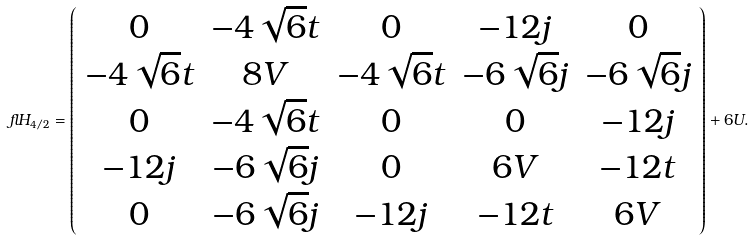<formula> <loc_0><loc_0><loc_500><loc_500>\ f l H _ { 4 / 2 } = \left ( \begin{array} { c c c c c } 0 & - 4 \sqrt { 6 } t & 0 & - 1 2 j & 0 \\ - 4 \sqrt { 6 } t & 8 V & - 4 \sqrt { 6 } t & - 6 \sqrt { 6 } j & - 6 \sqrt { 6 } j \\ 0 & - 4 \sqrt { 6 } t & 0 & 0 & - 1 2 j \\ - 1 2 j & - 6 \sqrt { 6 } j & 0 & 6 V & - 1 2 t \\ 0 & - 6 \sqrt { 6 } j & - 1 2 j & - 1 2 t & 6 V \\ \end{array} \right ) + 6 U .</formula> 